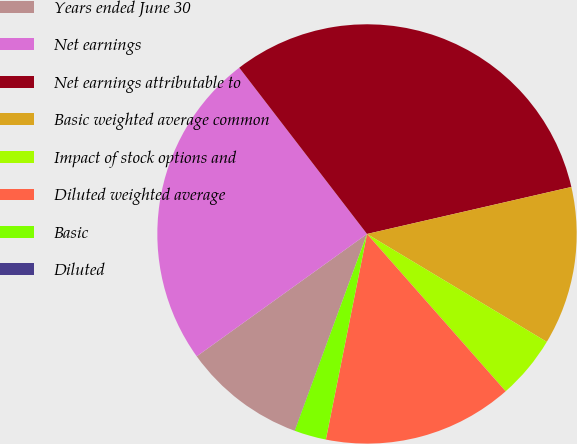Convert chart to OTSL. <chart><loc_0><loc_0><loc_500><loc_500><pie_chart><fcel>Years ended June 30<fcel>Net earnings<fcel>Net earnings attributable to<fcel>Basic weighted average common<fcel>Impact of stock options and<fcel>Diluted weighted average<fcel>Basic<fcel>Diluted<nl><fcel>9.47%<fcel>24.49%<fcel>31.83%<fcel>12.2%<fcel>4.9%<fcel>14.64%<fcel>2.46%<fcel>0.01%<nl></chart> 